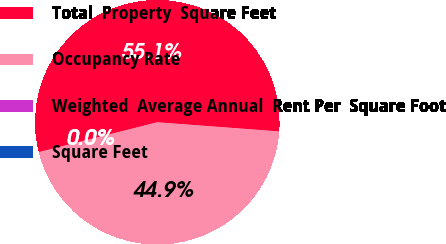<chart> <loc_0><loc_0><loc_500><loc_500><pie_chart><fcel>Total  Property  Square Feet<fcel>Occupancy Rate<fcel>Weighted  Average Annual  Rent Per  Square Foot<fcel>Square Feet<nl><fcel>55.12%<fcel>44.87%<fcel>0.0%<fcel>0.0%<nl></chart> 